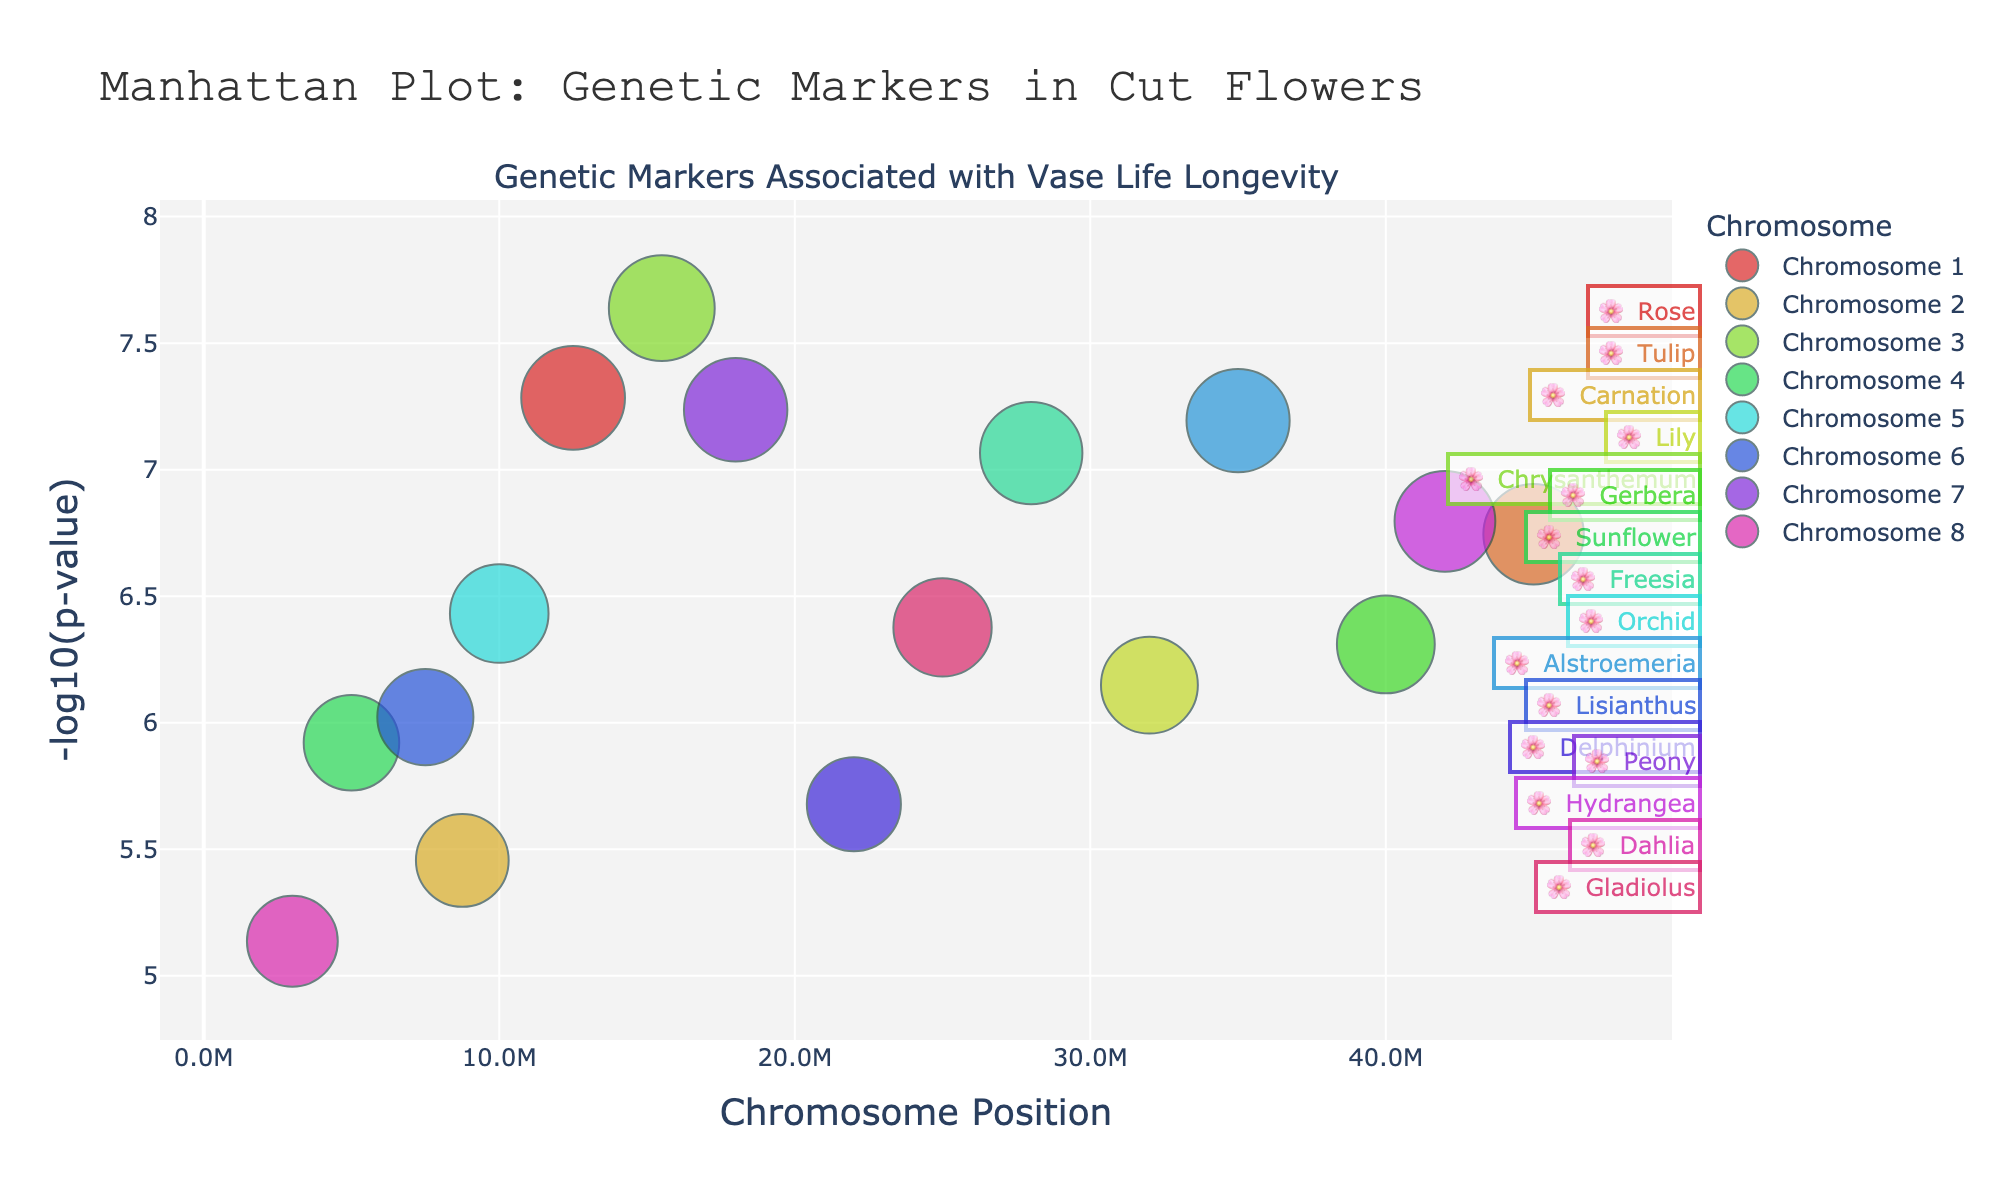What is the title of the plot? The title is provided at the top center of the plot.
Answer: Manhattan Plot: Genetic Markers in Cut Flowers Which chromosome has the genetic marker with the lowest p-value? The genetic marker with the lowest p-value will have the highest -log10(p-value). Locate the highest point on the plot and identify its corresponding chromosome.
Answer: Chromosome 3 What is the y-axis measuring? The y-axis label is provided on the plot and indicates what the axis represents.
Answer: -log10(p-value) How many genetic markers are plotted for chromosome 6? Look for the markers scattered along the x-axis labeled chromosome 6 and count them.
Answer: 2 Which flower type appears most frequently among the genetic markers? Identify the flower type labels for each point and count the occurrences. Compare counts to find the most frequent one.
Answer: Multiple flower types occur once, so no single most frequent type Which chromosome has the most genetic markers plotted? Count the number of markers for each chromosome by looking at the plot.
Answer: Chromosome 4 What is the position of the gene SAG12? Locate the gene name SAG12 on the plot and note its x-axis value.
Answer: 15500000 What is the flower type associated with the gene FLT1? Locate the gene FLT1 on the plot and note the associated flower type provided in the hovertext.
Answer: Rose Are there any genetic markers with a p-value less than 1e-7 on chromosome 7? Identify markers on chromosome 7 and check if any have a higher -log10(p-value) than -log10(1e-7) (i.e., >7).
Answer: Yes How do the genetic markers for flowers in chromosome 1 compare in terms of p-values? Compare the heights (-log10(p-values)) of the markers for flowers in chromosome 1 on the plot.
Answer: The marker for Rose has a lower p-value than that for Tulip 